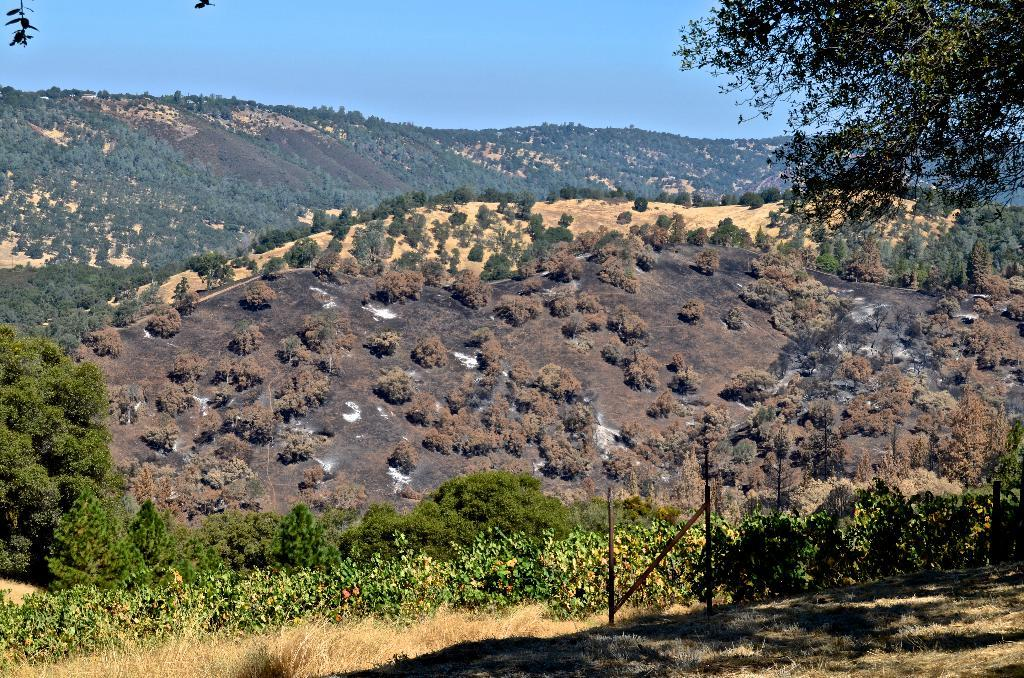What is the main subject of the image? The image depicts a mountain. What type of vegetation can be seen on the mountain? There are trees on the mountain. What is visible at the top of the image? The sky is visible at the top of the image. What is present at the bottom of the image? Grass is present at the bottom of the image. What can be seen in the middle of the image? There are poles in the middle of the image. What type of badge can be seen hanging from the trees on the mountain? There is no badge present in the image; it only features a mountain, trees, sky, grass, and poles. How many hooks are visible on the mountain in the image? There are no hooks visible in the image; it only features a mountain, trees, sky, grass, and poles. 